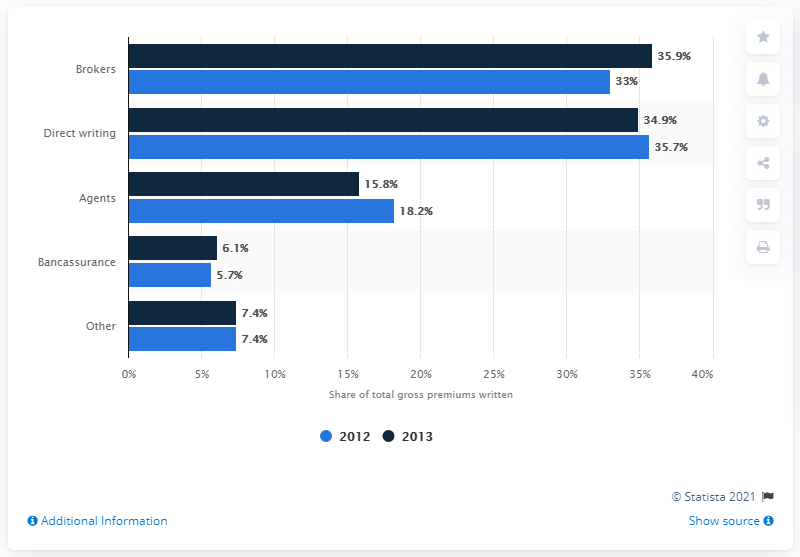Indicate a few pertinent items in this graphic. The supply channel that had the same value in 2012 and 2013 was Other. In 2013, approximately 34.9% of non-life insurance products in Austria were supplied directly by insurance companies. In Austria, the largest non-life insurance distribution channel was brokers. In 2013, broker accounts represented approximately 35.9% of Austria's market. 